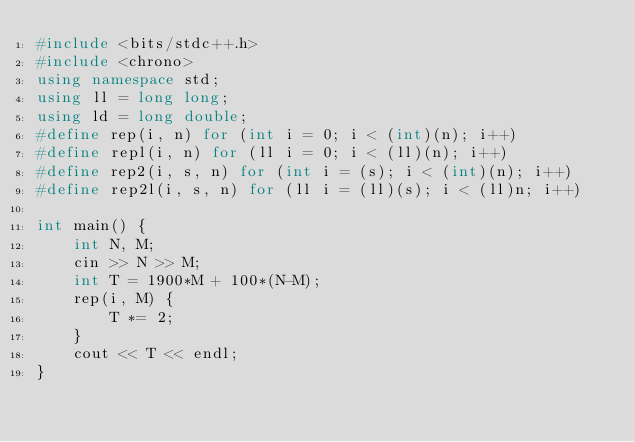Convert code to text. <code><loc_0><loc_0><loc_500><loc_500><_C++_>#include <bits/stdc++.h>
#include <chrono>
using namespace std;
using ll = long long;
using ld = long double;
#define rep(i, n) for (int i = 0; i < (int)(n); i++)
#define repl(i, n) for (ll i = 0; i < (ll)(n); i++)
#define rep2(i, s, n) for (int i = (s); i < (int)(n); i++)
#define rep2l(i, s, n) for (ll i = (ll)(s); i < (ll)n; i++)

int main() {
    int N, M;
    cin >> N >> M;
    int T = 1900*M + 100*(N-M);
    rep(i, M) {
        T *= 2;
    }
    cout << T << endl;
}</code> 